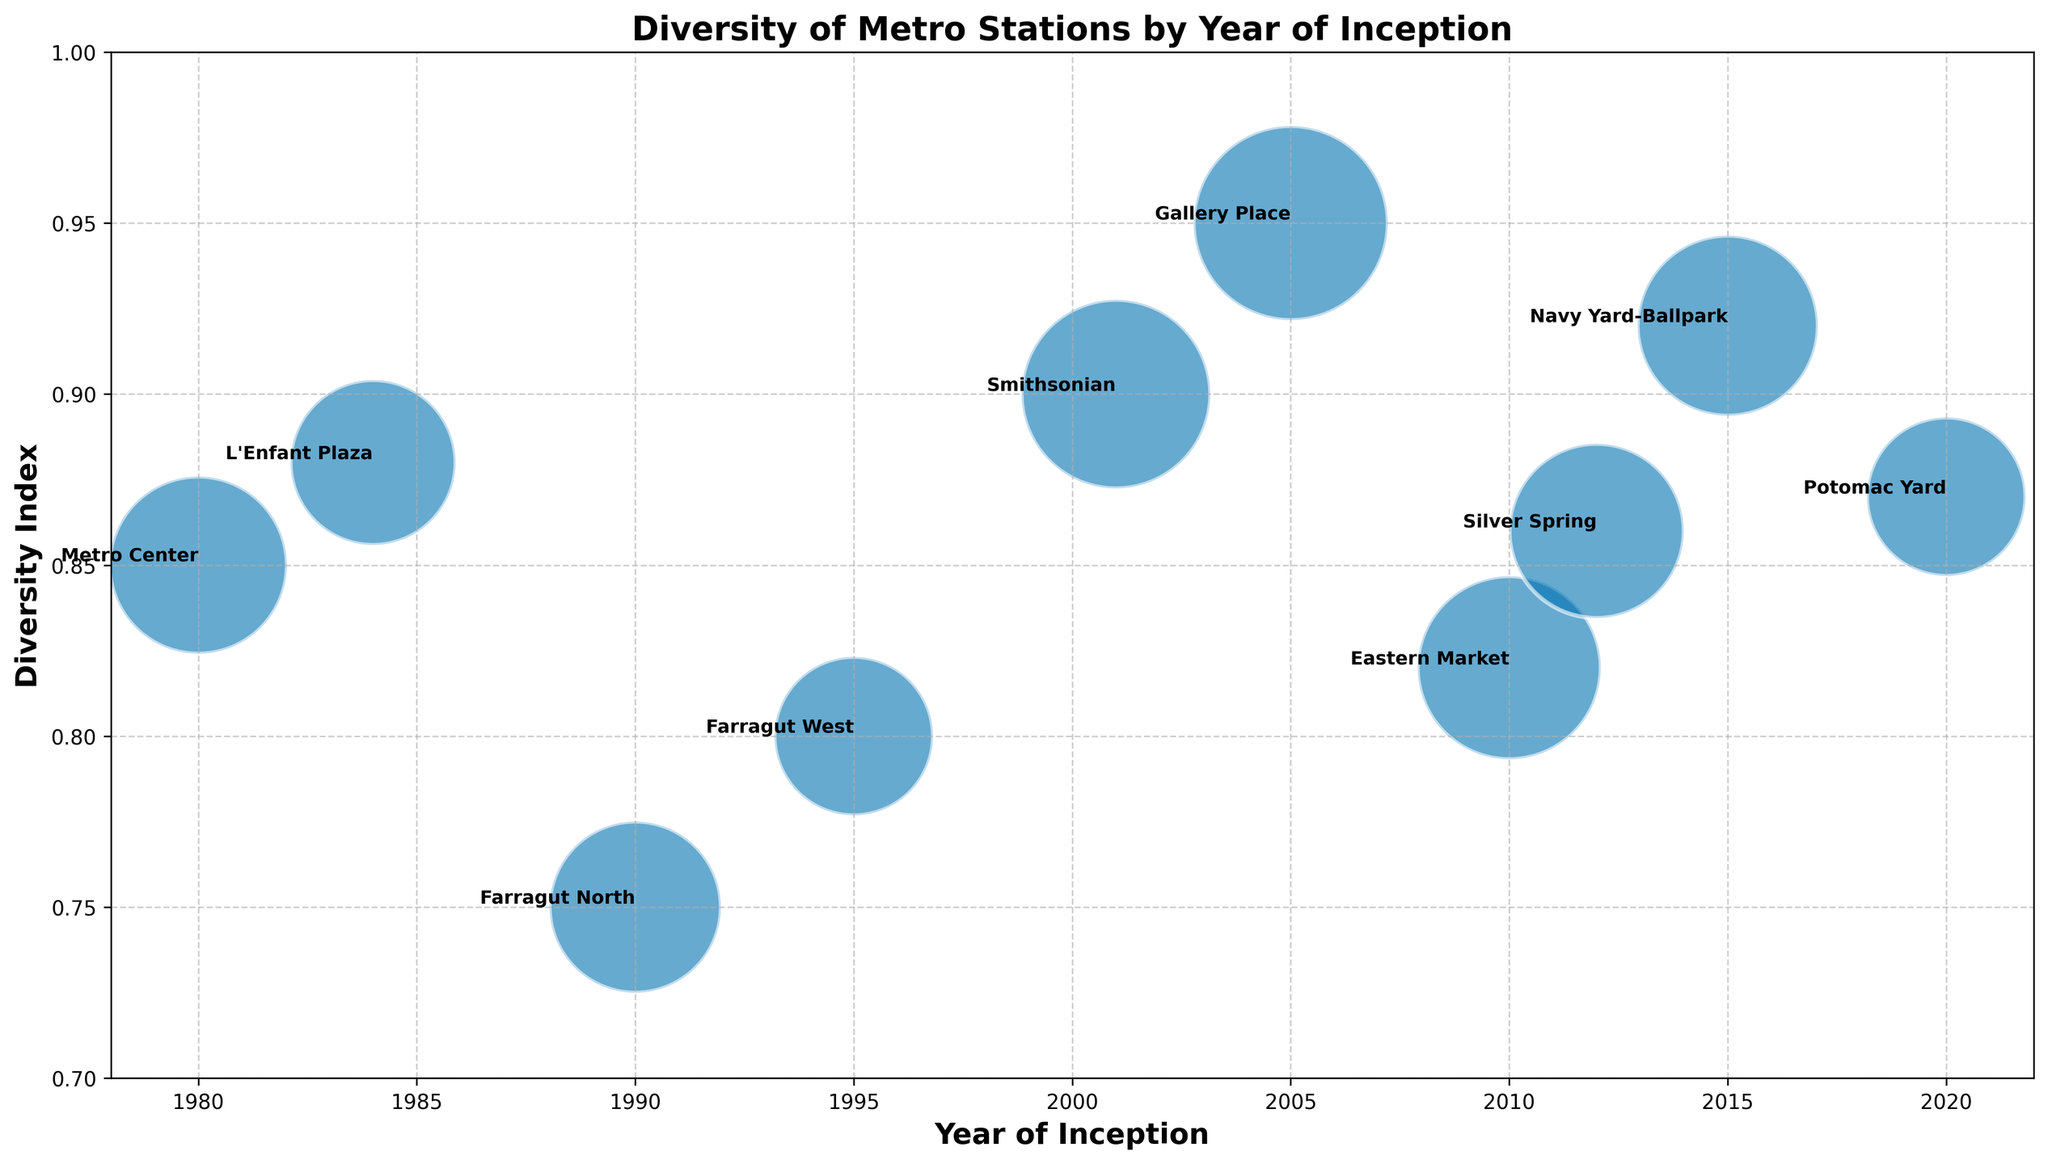Which station was inaugurated most recently, and what is its diversity index? The most recent station according to the x-axis (year of inception) is "Potomac Yard" in 2020. The corresponding point on the y-axis shows a diversity index of 0.87.
Answer: Potomac Yard, 0.87 What is the range of diversity indices for the listed metro stations? The lowest diversity index visible is 0.75 (Farragut North, 1990) and the highest is 0.95 (Gallery Place, 2005). Thus, the range is 0.95 - 0.75 = 0.20.
Answer: 0.20 Which station has the largest bubble and what does this indicate? The largest bubble represents the station with the highest passenger count, which is "Gallery Place" with a passenger count of 1,800,000, as indicated by the size of the bubble.
Answer: Gallery Place Compare the diversity indices of the stations inaugurated in the 1980s. The stations from the 1980s are "Metro Center" (1980) with a diversity index of 0.85 and "L'Enfant Plaza" (1984) with a diversity index of 0.88. L'Enfant Plaza has a slightly higher diversity index than Metro Center.
Answer: L'Enfant Plaza > Metro Center Which station inaugurated in 2005 has the highest diversity index and what is its passenger count? The station inaugurated in 2005 is "Gallery Place" with a diversity index of 0.95. Its passenger count, indicated by the size of the bubble, is 1,800,000.
Answer: Gallery Place, 1,800,000 Identify the stations with a diversity index above 0.9 and list their inauguration years. The stations with a diversity index above 0.9 are "Smithsonian" (2001) with 0.90, "Gallery Place" (2005) with 0.95, and "Navy Yard-Ballpark" (2015) with 0.92.
Answer: Smithsonian (2001), Gallery Place (2005), Navy Yard-Ballpark (2015) What is the average diversity index of the stations inaugurated after the year 2000? Stations inaugurated after 2000 are "Smithsonian" (0.90), "Gallery Place" (0.95), "Eastern Market" (0.82), "Silver Spring" (0.86), "Navy Yard-Ballpark" (0.92), and "Potomac Yard" (0.87). The average is (0.90 + 0.95 + 0.82 + 0.86 + 0.92 + 0.87) / 6 = 0.88.
Answer: 0.88 Which station with a diversity index of at least 0.85 has the lowest passenger count? Filtering stations with a diversity index of at least 0.85, "Potomac Yard" (2020) has the lowest passenger count at 1,200,000.
Answer: Potomac Yard How many stations have both a diversity index greater than 0.85 and a passenger count greater than 1,500,000? Stations meeting both criteria are "Smithsonian" (1,700,000), "Gallery Place" (1,800,000), and "Eastern Market" (1,600,000) for a total of 3 stations.
Answer: 3 